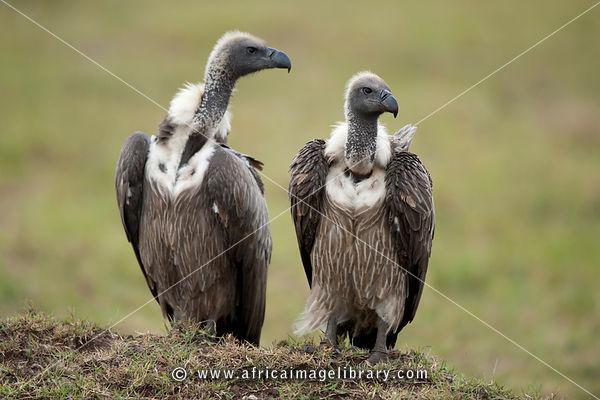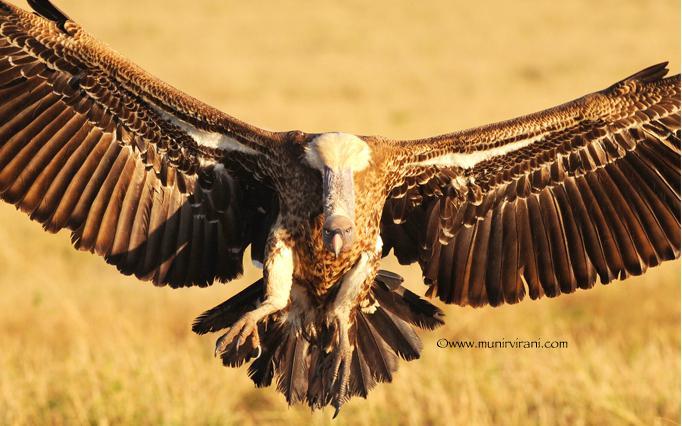The first image is the image on the left, the second image is the image on the right. Evaluate the accuracy of this statement regarding the images: "In at least one image there is a closeup of a lone vultures face". Is it true? Answer yes or no. No. The first image is the image on the left, the second image is the image on the right. For the images shown, is this caption "The left image has two birds while the right only has one." true? Answer yes or no. Yes. 